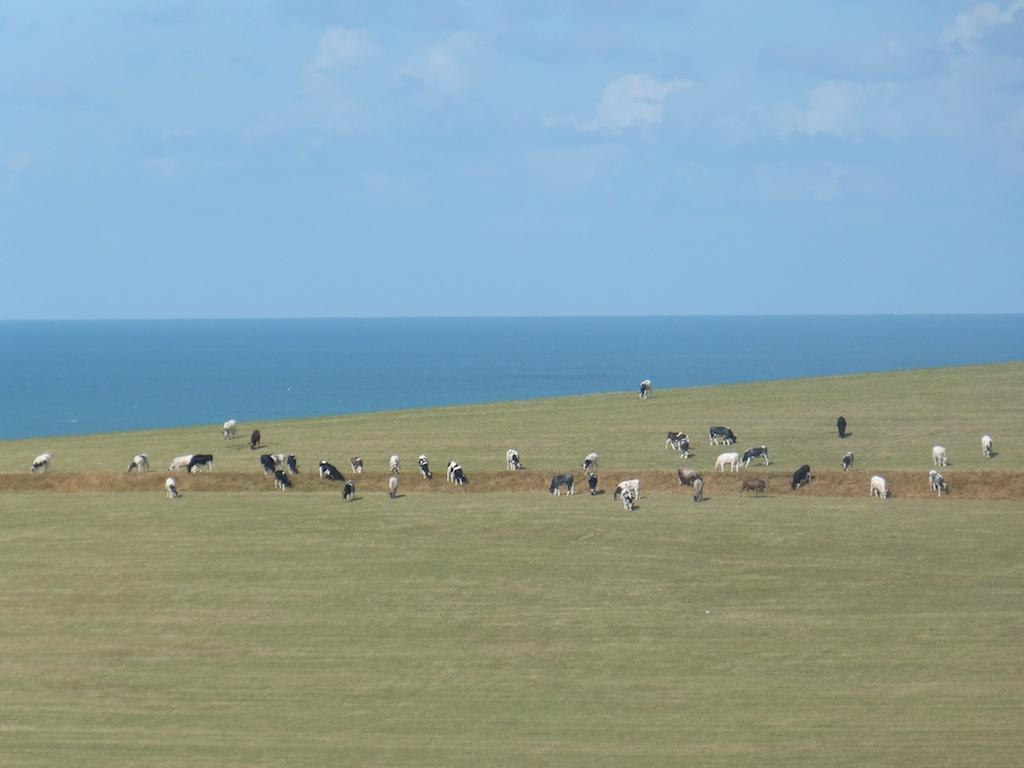What type of landscape is visible in the image? There is an open land beside the sea in the image. What can be seen on the open land? Many animals are grazing the grass in the open land. Where is the volleyball court located in the image? There is no volleyball court present in the image. What type of activity is taking place during recess in the image? There is no mention of recess or any related activities in the image. 